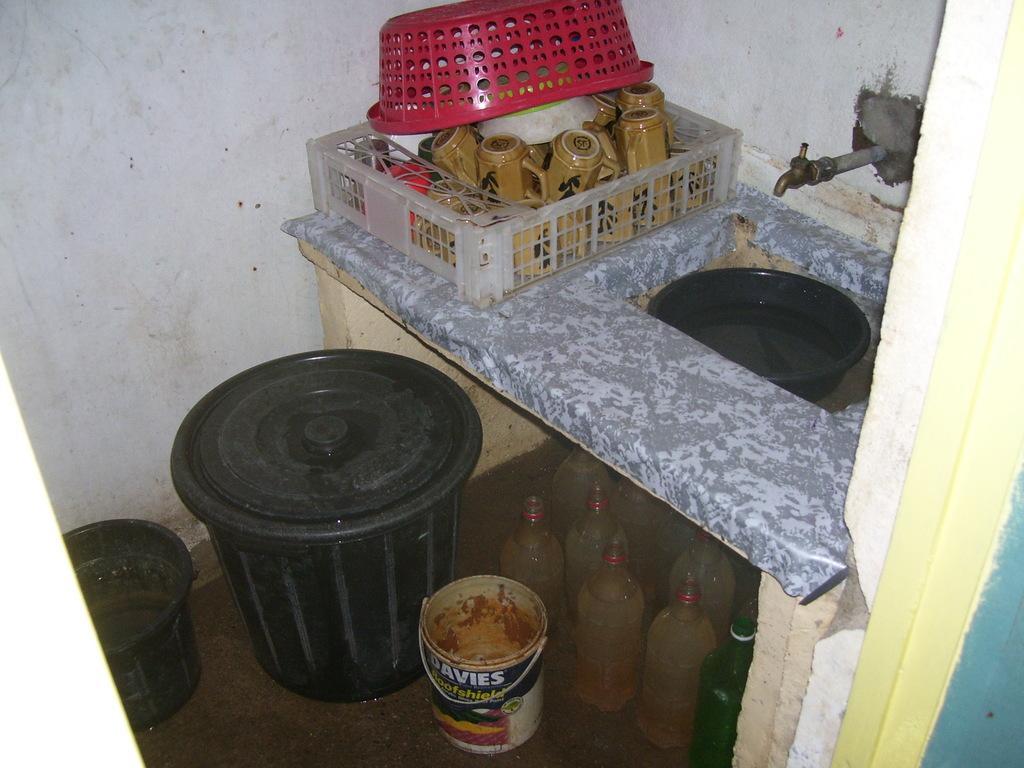Describe this image in one or two sentences. In this picture there are few cups placed in an object and there is a wash basin beside it which has a black tube placed in it and there is a black plastic box,a bucket and some other objects beside it. 